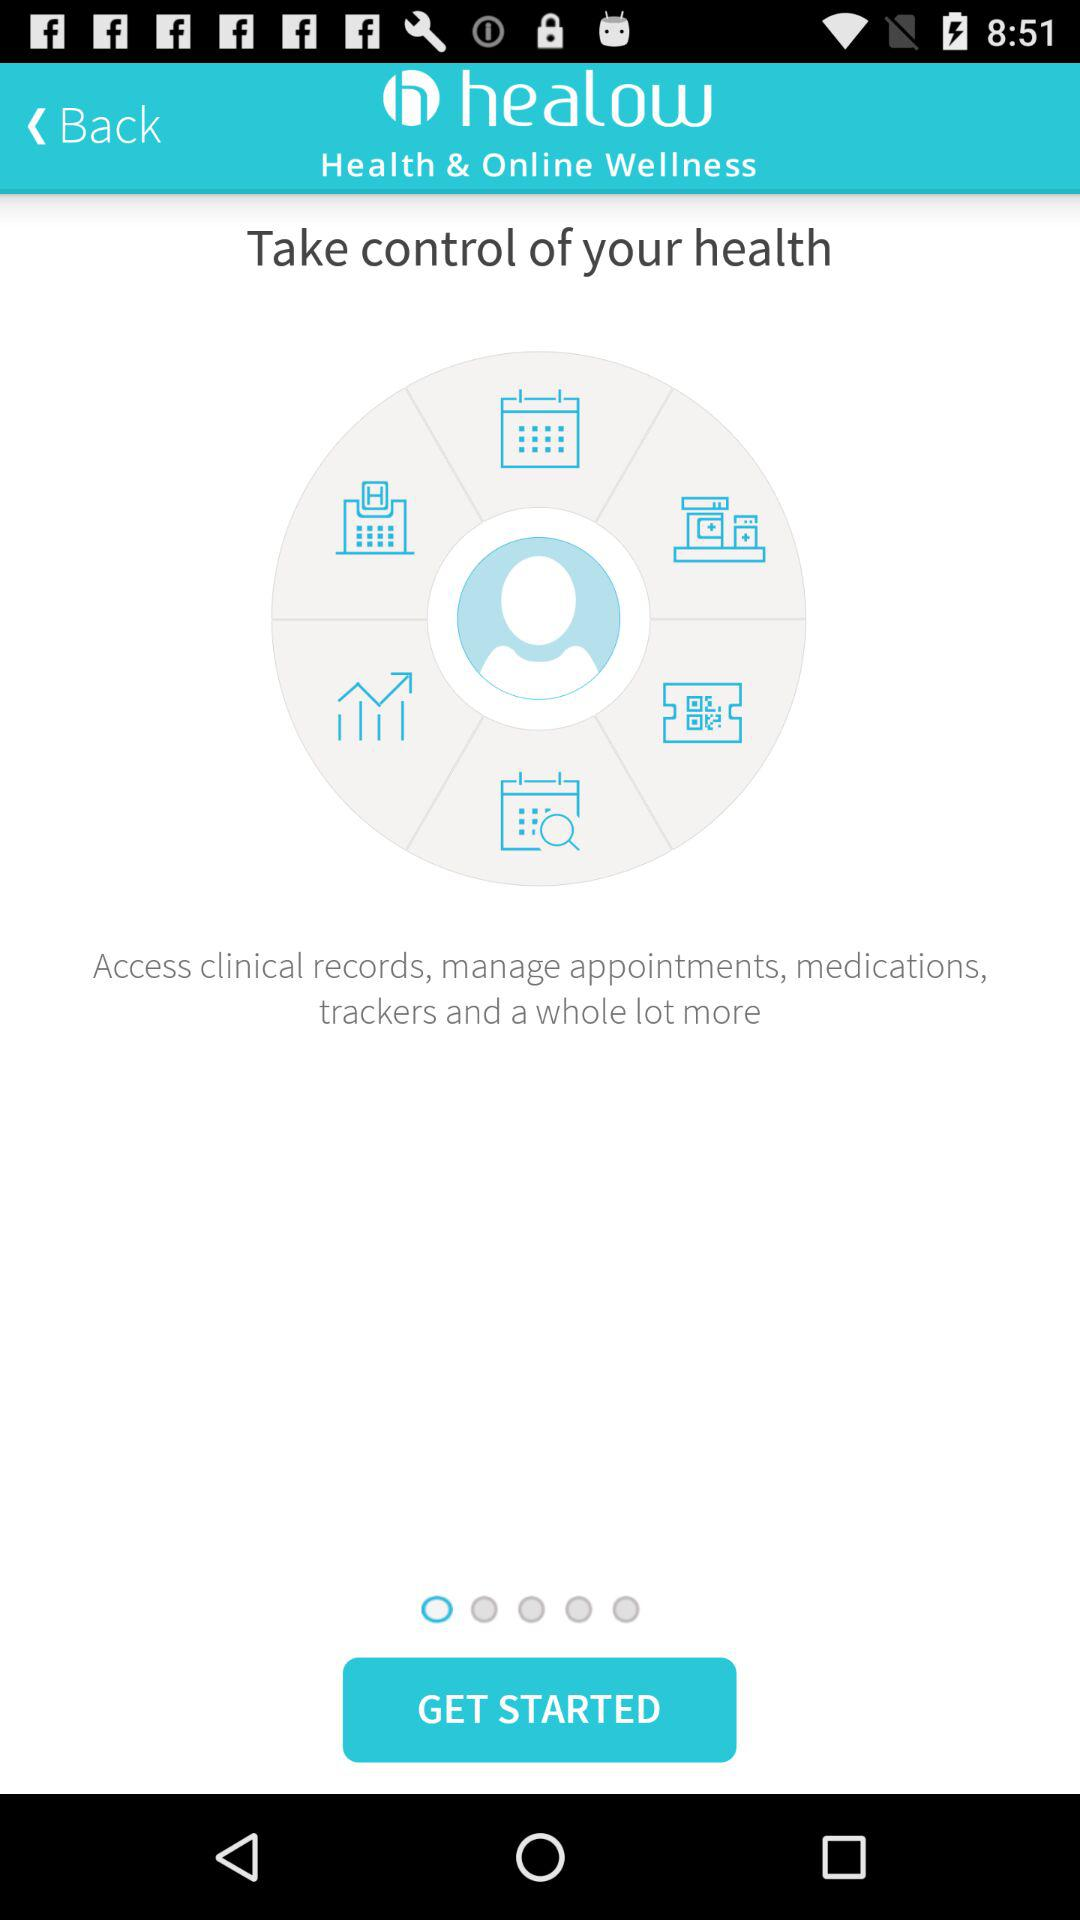What is the application name? The application name is "healow". 